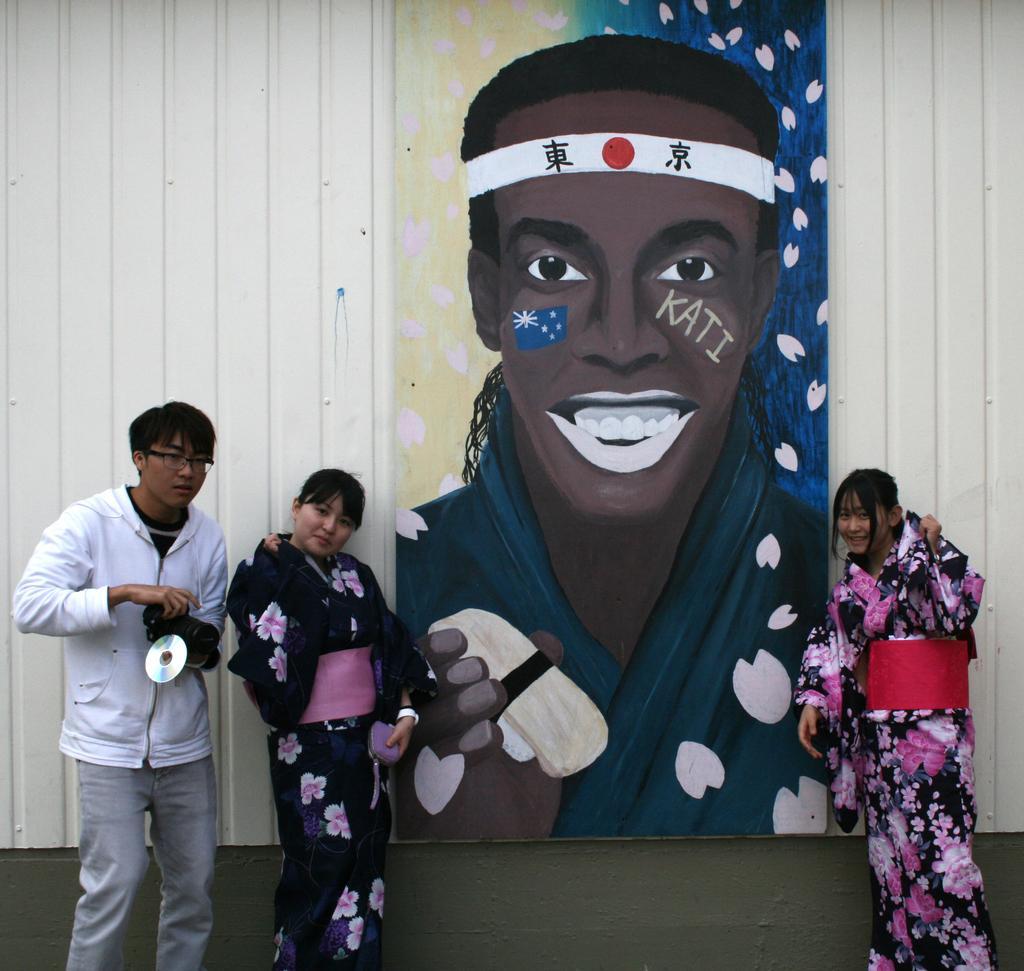In one or two sentences, can you explain what this image depicts? In this picture there are two persons standing and smiling and there is a person with white jacket is standing and holding the camera. At the back there is a painting of a person on the board and at the back there is a wall. 